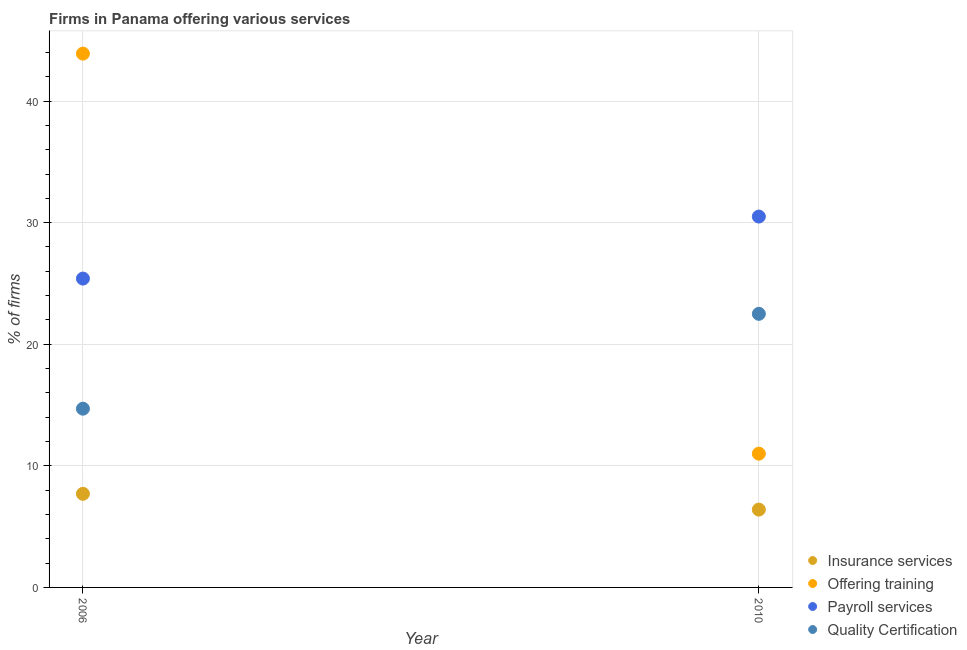How many different coloured dotlines are there?
Offer a terse response. 4. What is the percentage of firms offering insurance services in 2006?
Give a very brief answer. 7.7. Across all years, what is the minimum percentage of firms offering payroll services?
Give a very brief answer. 25.4. In which year was the percentage of firms offering insurance services maximum?
Provide a succinct answer. 2006. In which year was the percentage of firms offering quality certification minimum?
Your response must be concise. 2006. What is the total percentage of firms offering training in the graph?
Keep it short and to the point. 54.9. What is the difference between the percentage of firms offering insurance services in 2006 and that in 2010?
Offer a very short reply. 1.3. What is the difference between the percentage of firms offering quality certification in 2010 and the percentage of firms offering payroll services in 2006?
Keep it short and to the point. -2.9. What is the average percentage of firms offering insurance services per year?
Ensure brevity in your answer.  7.05. In how many years, is the percentage of firms offering quality certification greater than 30 %?
Provide a succinct answer. 0. What is the ratio of the percentage of firms offering training in 2006 to that in 2010?
Provide a short and direct response. 3.99. Is it the case that in every year, the sum of the percentage of firms offering payroll services and percentage of firms offering training is greater than the sum of percentage of firms offering quality certification and percentage of firms offering insurance services?
Offer a very short reply. No. Is it the case that in every year, the sum of the percentage of firms offering insurance services and percentage of firms offering training is greater than the percentage of firms offering payroll services?
Offer a terse response. No. Is the percentage of firms offering insurance services strictly greater than the percentage of firms offering training over the years?
Offer a terse response. No. Is the percentage of firms offering insurance services strictly less than the percentage of firms offering quality certification over the years?
Your response must be concise. Yes. Where does the legend appear in the graph?
Provide a short and direct response. Bottom right. How many legend labels are there?
Keep it short and to the point. 4. How are the legend labels stacked?
Give a very brief answer. Vertical. What is the title of the graph?
Offer a terse response. Firms in Panama offering various services . Does "Taxes on revenue" appear as one of the legend labels in the graph?
Give a very brief answer. No. What is the label or title of the Y-axis?
Provide a short and direct response. % of firms. What is the % of firms in Offering training in 2006?
Your answer should be very brief. 43.9. What is the % of firms in Payroll services in 2006?
Offer a very short reply. 25.4. What is the % of firms of Quality Certification in 2006?
Ensure brevity in your answer.  14.7. What is the % of firms of Payroll services in 2010?
Your response must be concise. 30.5. What is the % of firms in Quality Certification in 2010?
Provide a succinct answer. 22.5. Across all years, what is the maximum % of firms of Offering training?
Offer a very short reply. 43.9. Across all years, what is the maximum % of firms in Payroll services?
Keep it short and to the point. 30.5. Across all years, what is the minimum % of firms in Payroll services?
Your answer should be very brief. 25.4. What is the total % of firms in Offering training in the graph?
Offer a very short reply. 54.9. What is the total % of firms in Payroll services in the graph?
Your answer should be compact. 55.9. What is the total % of firms in Quality Certification in the graph?
Your answer should be very brief. 37.2. What is the difference between the % of firms in Insurance services in 2006 and that in 2010?
Your response must be concise. 1.3. What is the difference between the % of firms of Offering training in 2006 and that in 2010?
Ensure brevity in your answer.  32.9. What is the difference between the % of firms in Payroll services in 2006 and that in 2010?
Your answer should be very brief. -5.1. What is the difference between the % of firms of Quality Certification in 2006 and that in 2010?
Give a very brief answer. -7.8. What is the difference between the % of firms of Insurance services in 2006 and the % of firms of Payroll services in 2010?
Your answer should be compact. -22.8. What is the difference between the % of firms in Insurance services in 2006 and the % of firms in Quality Certification in 2010?
Ensure brevity in your answer.  -14.8. What is the difference between the % of firms in Offering training in 2006 and the % of firms in Payroll services in 2010?
Keep it short and to the point. 13.4. What is the difference between the % of firms in Offering training in 2006 and the % of firms in Quality Certification in 2010?
Your answer should be very brief. 21.4. What is the average % of firms of Insurance services per year?
Give a very brief answer. 7.05. What is the average % of firms in Offering training per year?
Your answer should be compact. 27.45. What is the average % of firms in Payroll services per year?
Make the answer very short. 27.95. What is the average % of firms of Quality Certification per year?
Your answer should be very brief. 18.6. In the year 2006, what is the difference between the % of firms of Insurance services and % of firms of Offering training?
Keep it short and to the point. -36.2. In the year 2006, what is the difference between the % of firms of Insurance services and % of firms of Payroll services?
Offer a terse response. -17.7. In the year 2006, what is the difference between the % of firms of Insurance services and % of firms of Quality Certification?
Provide a short and direct response. -7. In the year 2006, what is the difference between the % of firms in Offering training and % of firms in Payroll services?
Keep it short and to the point. 18.5. In the year 2006, what is the difference between the % of firms in Offering training and % of firms in Quality Certification?
Your answer should be compact. 29.2. In the year 2010, what is the difference between the % of firms of Insurance services and % of firms of Offering training?
Your answer should be very brief. -4.6. In the year 2010, what is the difference between the % of firms in Insurance services and % of firms in Payroll services?
Keep it short and to the point. -24.1. In the year 2010, what is the difference between the % of firms of Insurance services and % of firms of Quality Certification?
Give a very brief answer. -16.1. In the year 2010, what is the difference between the % of firms in Offering training and % of firms in Payroll services?
Ensure brevity in your answer.  -19.5. In the year 2010, what is the difference between the % of firms in Offering training and % of firms in Quality Certification?
Offer a terse response. -11.5. What is the ratio of the % of firms of Insurance services in 2006 to that in 2010?
Make the answer very short. 1.2. What is the ratio of the % of firms of Offering training in 2006 to that in 2010?
Your answer should be very brief. 3.99. What is the ratio of the % of firms in Payroll services in 2006 to that in 2010?
Make the answer very short. 0.83. What is the ratio of the % of firms of Quality Certification in 2006 to that in 2010?
Make the answer very short. 0.65. What is the difference between the highest and the second highest % of firms in Offering training?
Keep it short and to the point. 32.9. What is the difference between the highest and the second highest % of firms in Payroll services?
Your answer should be very brief. 5.1. What is the difference between the highest and the second highest % of firms of Quality Certification?
Your response must be concise. 7.8. What is the difference between the highest and the lowest % of firms of Insurance services?
Keep it short and to the point. 1.3. What is the difference between the highest and the lowest % of firms in Offering training?
Your answer should be compact. 32.9. What is the difference between the highest and the lowest % of firms of Payroll services?
Your answer should be compact. 5.1. 